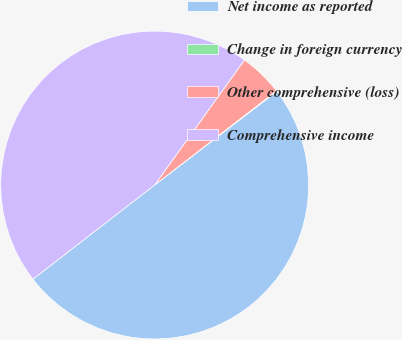Convert chart. <chart><loc_0><loc_0><loc_500><loc_500><pie_chart><fcel>Net income as reported<fcel>Change in foreign currency<fcel>Other comprehensive (loss)<fcel>Comprehensive income<nl><fcel>49.92%<fcel>0.08%<fcel>4.61%<fcel>45.39%<nl></chart> 